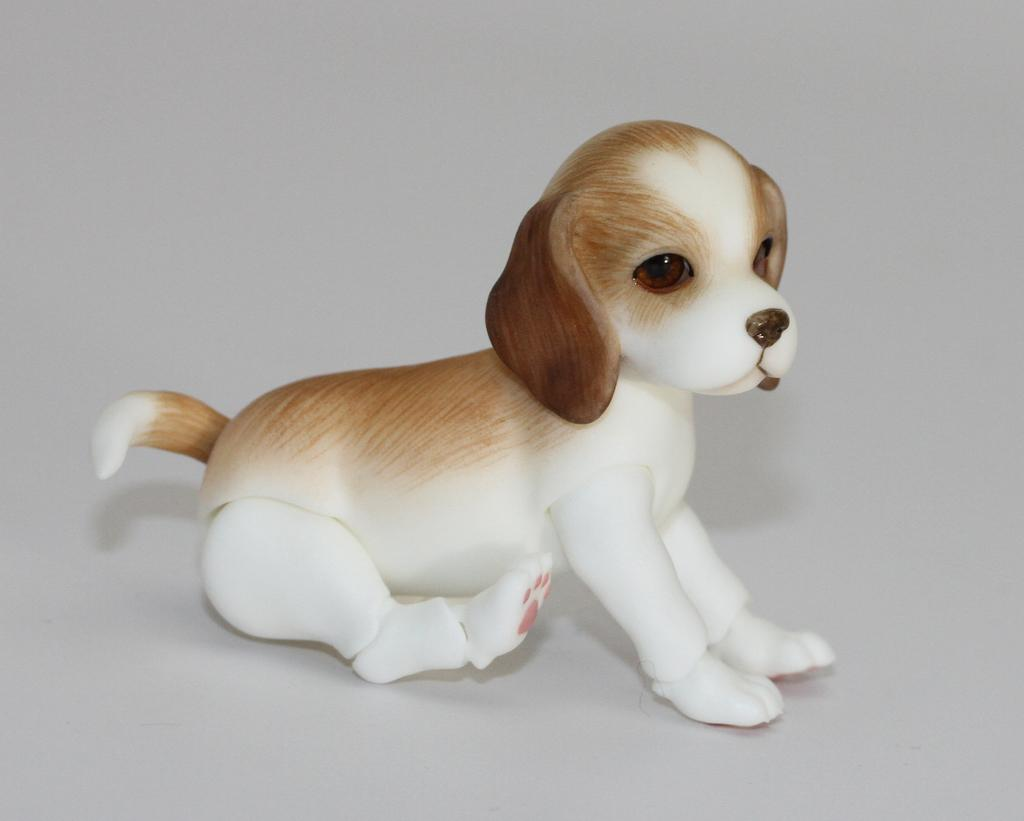What object is present on the floor in the image? There is a dog toy sitting on the floor in the image. What can be seen in the background of the image? The background of the image is white. Where is the tramp located in the image? There is no tramp present in the image. What type of gate can be seen in the image? There is no gate present in the image. 